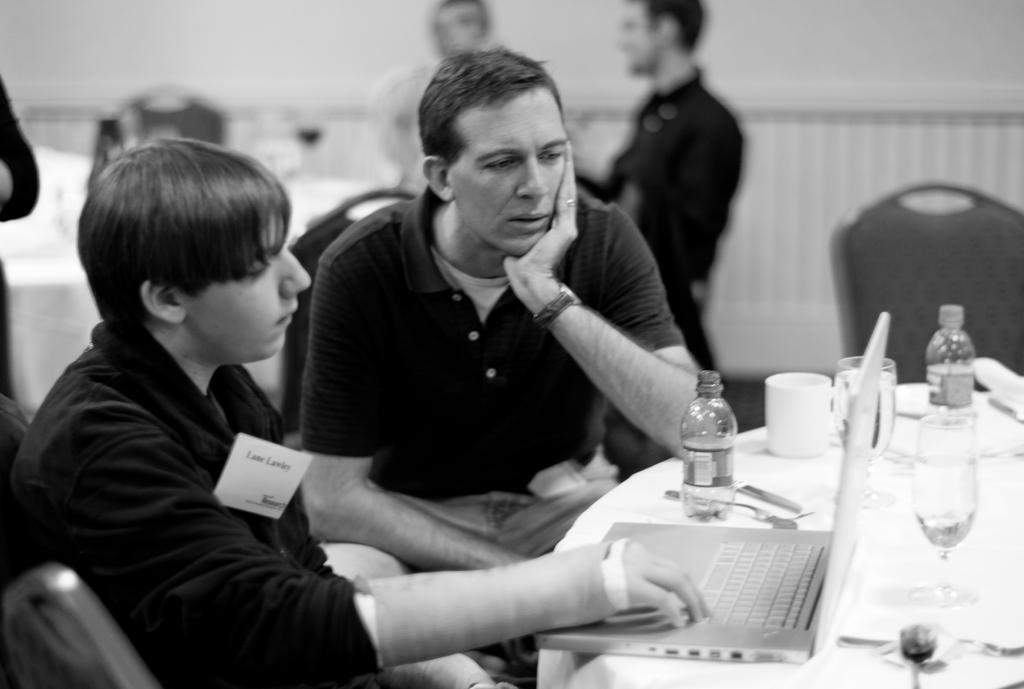What are the people in the image doing? The people in the image are standing and sitting. What type of furniture is present in the image? There are chairs and a table in the image. What items can be seen on the table? There are glasses, cups, bottles, and a laptop on the table. What type of pest can be seen crawling on the laptop in the image? There are no pests visible in the image, and the laptop is not being crawled on. 